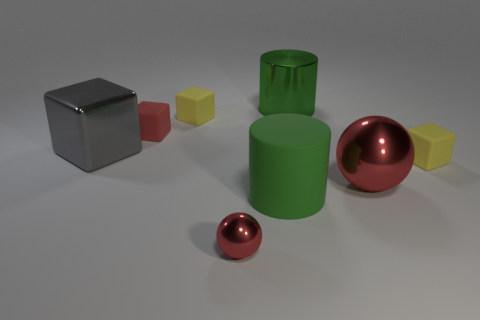There is a red shiny object that is left of the red ball that is right of the matte cylinder; what shape is it?
Keep it short and to the point. Sphere. There is a small yellow rubber cube behind the gray metal cube; how many red objects are to the left of it?
Your response must be concise. 1. There is a red thing that is both on the left side of the large red thing and in front of the big gray object; what is it made of?
Your answer should be very brief. Metal. There is a green shiny thing that is the same size as the gray metal object; what is its shape?
Give a very brief answer. Cylinder. The object in front of the rubber cylinder that is in front of the yellow cube behind the tiny red rubber cube is what color?
Your answer should be compact. Red. How many things are either matte things that are on the left side of the small ball or blue rubber objects?
Provide a short and direct response. 2. What material is the red ball that is the same size as the gray object?
Keep it short and to the point. Metal. What material is the cylinder on the right side of the green thing that is in front of the large green cylinder behind the big cube?
Make the answer very short. Metal. What is the color of the large metal cylinder?
Provide a short and direct response. Green. How many small objects are yellow matte objects or gray objects?
Ensure brevity in your answer.  2. 